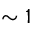Convert formula to latex. <formula><loc_0><loc_0><loc_500><loc_500>\sim 1</formula> 